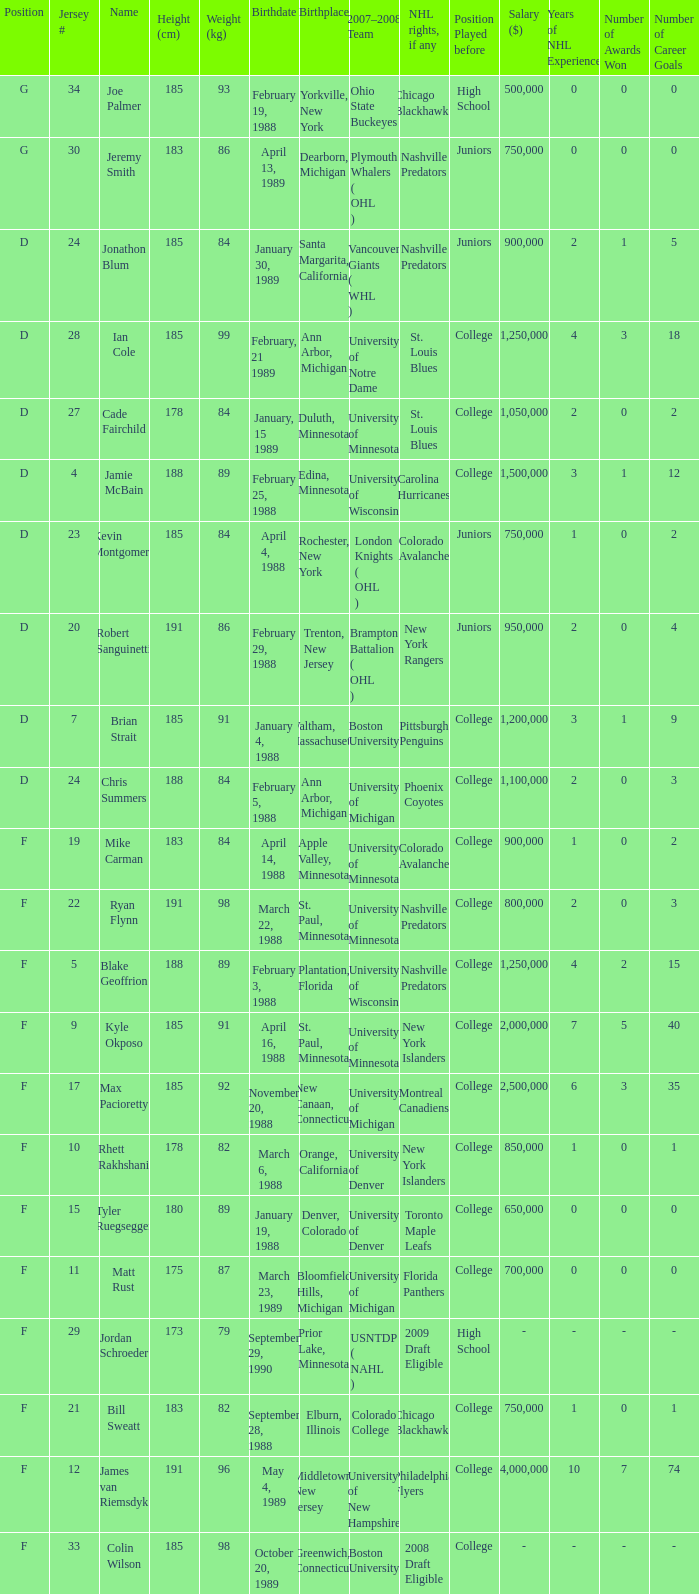Which Height (cm) has a Birthplace of bloomfield hills, michigan? 175.0. 